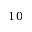Convert formula to latex. <formula><loc_0><loc_0><loc_500><loc_500>1 0</formula> 